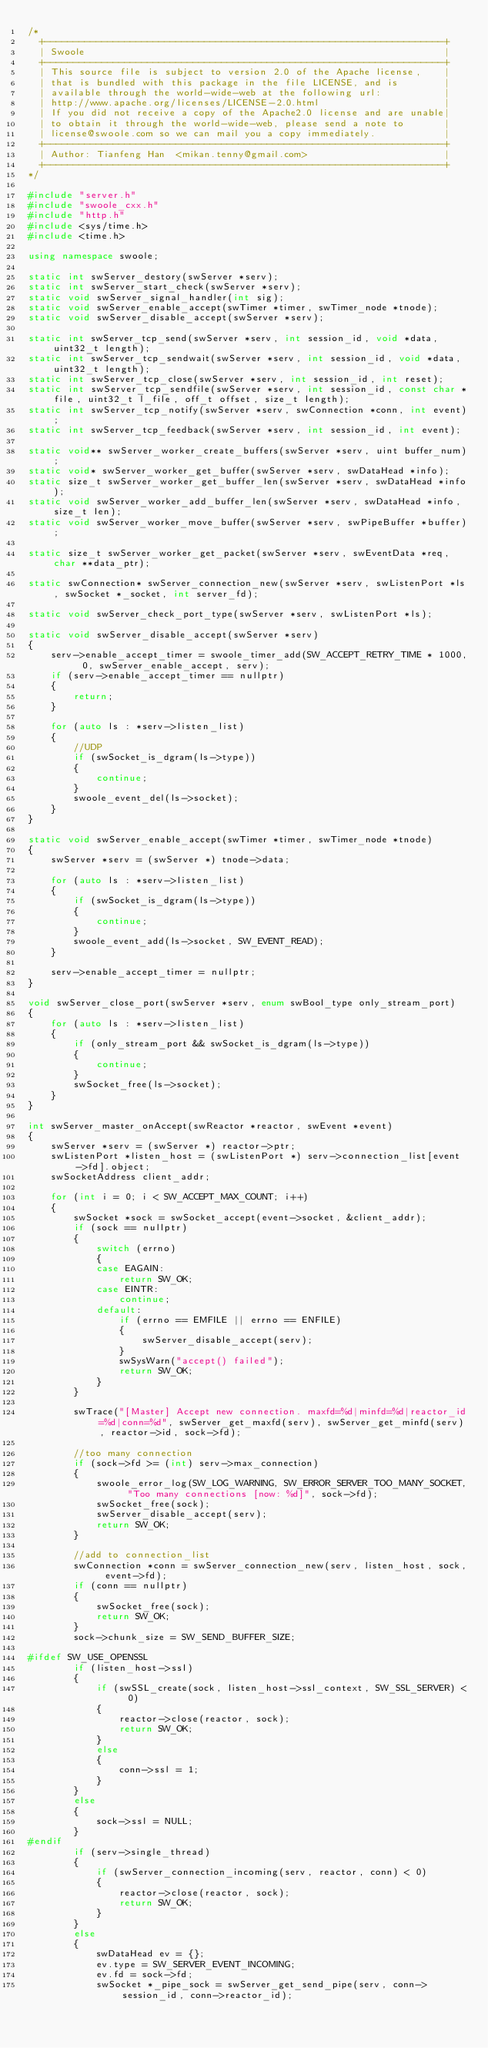<code> <loc_0><loc_0><loc_500><loc_500><_C++_>/*
  +----------------------------------------------------------------------+
  | Swoole                                                               |
  +----------------------------------------------------------------------+
  | This source file is subject to version 2.0 of the Apache license,    |
  | that is bundled with this package in the file LICENSE, and is        |
  | available through the world-wide-web at the following url:           |
  | http://www.apache.org/licenses/LICENSE-2.0.html                      |
  | If you did not receive a copy of the Apache2.0 license and are unable|
  | to obtain it through the world-wide-web, please send a note to       |
  | license@swoole.com so we can mail you a copy immediately.            |
  +----------------------------------------------------------------------+
  | Author: Tianfeng Han  <mikan.tenny@gmail.com>                        |
  +----------------------------------------------------------------------+
*/

#include "server.h"
#include "swoole_cxx.h"
#include "http.h"
#include <sys/time.h>
#include <time.h>

using namespace swoole;

static int swServer_destory(swServer *serv);
static int swServer_start_check(swServer *serv);
static void swServer_signal_handler(int sig);
static void swServer_enable_accept(swTimer *timer, swTimer_node *tnode);
static void swServer_disable_accept(swServer *serv);

static int swServer_tcp_send(swServer *serv, int session_id, void *data, uint32_t length);
static int swServer_tcp_sendwait(swServer *serv, int session_id, void *data, uint32_t length);
static int swServer_tcp_close(swServer *serv, int session_id, int reset);
static int swServer_tcp_sendfile(swServer *serv, int session_id, const char *file, uint32_t l_file, off_t offset, size_t length);
static int swServer_tcp_notify(swServer *serv, swConnection *conn, int event);
static int swServer_tcp_feedback(swServer *serv, int session_id, int event);

static void** swServer_worker_create_buffers(swServer *serv, uint buffer_num);
static void* swServer_worker_get_buffer(swServer *serv, swDataHead *info);
static size_t swServer_worker_get_buffer_len(swServer *serv, swDataHead *info);
static void swServer_worker_add_buffer_len(swServer *serv, swDataHead *info, size_t len);
static void swServer_worker_move_buffer(swServer *serv, swPipeBuffer *buffer);

static size_t swServer_worker_get_packet(swServer *serv, swEventData *req, char **data_ptr);

static swConnection* swServer_connection_new(swServer *serv, swListenPort *ls, swSocket *_socket, int server_fd);

static void swServer_check_port_type(swServer *serv, swListenPort *ls);

static void swServer_disable_accept(swServer *serv)
{
    serv->enable_accept_timer = swoole_timer_add(SW_ACCEPT_RETRY_TIME * 1000, 0, swServer_enable_accept, serv);
    if (serv->enable_accept_timer == nullptr)
    {
        return;
    }

    for (auto ls : *serv->listen_list)
    {
        //UDP
        if (swSocket_is_dgram(ls->type))
        {
            continue;
        }
        swoole_event_del(ls->socket);
    }
}

static void swServer_enable_accept(swTimer *timer, swTimer_node *tnode)
{
    swServer *serv = (swServer *) tnode->data;

    for (auto ls : *serv->listen_list)
    {
        if (swSocket_is_dgram(ls->type))
        {
            continue;
        }
        swoole_event_add(ls->socket, SW_EVENT_READ);
    }

    serv->enable_accept_timer = nullptr;
}

void swServer_close_port(swServer *serv, enum swBool_type only_stream_port)
{
    for (auto ls : *serv->listen_list)
    {
        if (only_stream_port && swSocket_is_dgram(ls->type))
        {
            continue;
        }
        swSocket_free(ls->socket);
    }
}

int swServer_master_onAccept(swReactor *reactor, swEvent *event)
{
    swServer *serv = (swServer *) reactor->ptr;
    swListenPort *listen_host = (swListenPort *) serv->connection_list[event->fd].object;
    swSocketAddress client_addr;

    for (int i = 0; i < SW_ACCEPT_MAX_COUNT; i++)
    {
        swSocket *sock = swSocket_accept(event->socket, &client_addr);
        if (sock == nullptr)
        {
            switch (errno)
            {
            case EAGAIN:
                return SW_OK;
            case EINTR:
                continue;
            default:
                if (errno == EMFILE || errno == ENFILE)
                {
                    swServer_disable_accept(serv);
                }
                swSysWarn("accept() failed");
                return SW_OK;
            }
        }

        swTrace("[Master] Accept new connection. maxfd=%d|minfd=%d|reactor_id=%d|conn=%d", swServer_get_maxfd(serv), swServer_get_minfd(serv), reactor->id, sock->fd);

        //too many connection
        if (sock->fd >= (int) serv->max_connection)
        {
            swoole_error_log(SW_LOG_WARNING, SW_ERROR_SERVER_TOO_MANY_SOCKET, "Too many connections [now: %d]", sock->fd);
            swSocket_free(sock);
            swServer_disable_accept(serv);
            return SW_OK;
        }

        //add to connection_list
        swConnection *conn = swServer_connection_new(serv, listen_host, sock, event->fd);
        if (conn == nullptr)
        {
            swSocket_free(sock);
            return SW_OK;
        }
        sock->chunk_size = SW_SEND_BUFFER_SIZE;

#ifdef SW_USE_OPENSSL
        if (listen_host->ssl)
        {
            if (swSSL_create(sock, listen_host->ssl_context, SW_SSL_SERVER) < 0)
            {
                reactor->close(reactor, sock);
                return SW_OK;
            }
            else
            {
                conn->ssl = 1;
            }
        }
        else
        {
            sock->ssl = NULL;
        }
#endif
        if (serv->single_thread)
        {
            if (swServer_connection_incoming(serv, reactor, conn) < 0)
            {
                reactor->close(reactor, sock);
                return SW_OK;
            }
        }
        else
        {
            swDataHead ev = {};
            ev.type = SW_SERVER_EVENT_INCOMING;
            ev.fd = sock->fd;
            swSocket *_pipe_sock = swServer_get_send_pipe(serv, conn->session_id, conn->reactor_id);</code> 